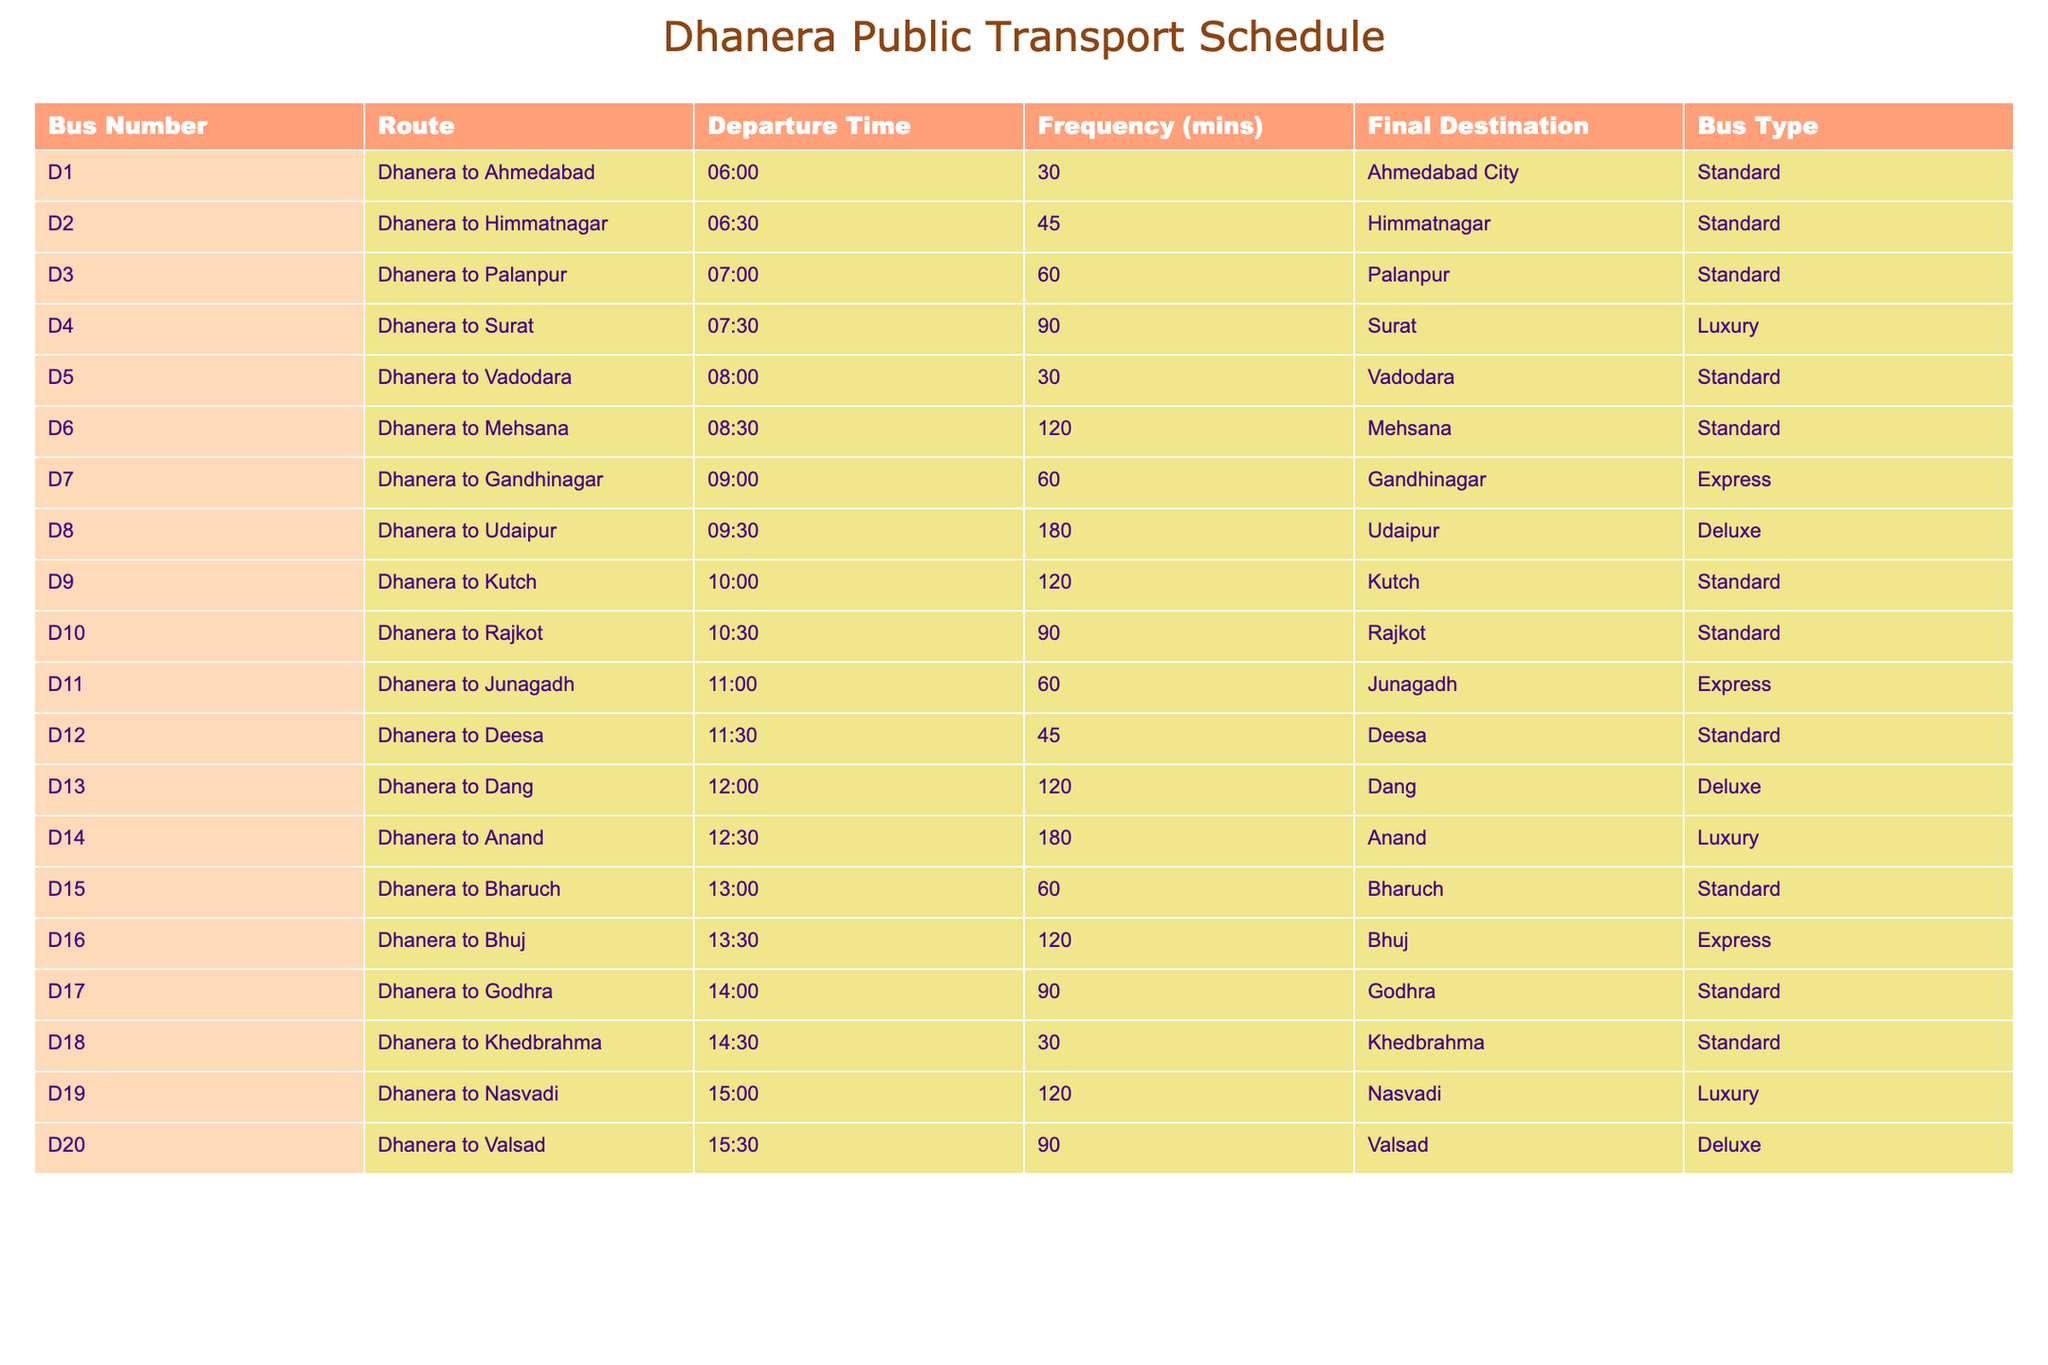What is the first bus to Ahmedabad? The table shows D1 is the bus number for the route from Dhanera to Ahmedabad and that it departs at 06:00.
Answer: D1 How frequently do buses to Himmatnagar run? The frequency for the Dhanera to Himmatnagar route (D2) is listed as 45 minutes.
Answer: 45 minutes What is the final destination of bus number D4? By checking bus number D4 in the table, it indicates that the final destination is Surat.
Answer: Surat Which bus route has the longest frequency? By comparing the frequencies listed, the longest frequency is 180 minutes for buses to Udaipur (D8) and Anand (D14).
Answer: Udaipur and Anand How many buses depart from Dhanera between 06:00 and 09:00? Counting the departures listed from 06:00 to 09:00, buses D1, D2, D3, D4, D5, and D6 depart during this time, totaling six buses.
Answer: 6 Is there a bus to Mehsana after 08:30? D6 departs to Mehsana at 08:30, which is the only bus listed for this route, meaning there are no further departures afterward.
Answer: No What type of bus travels to Rajkot? The table indicates that the bus number D10 traveling to Rajkot is a Standard type.
Answer: Standard What is the average frequency of buses departing after 13:00? The buses departing after 13:00 are D15 (60 mins), D16 (120 mins), D17 (90 mins), D18 (30 mins), D19 (120 mins), and D20 (90 mins). Adding these gives 60 + 120 + 90 + 30 + 120 + 90 = 510 minutes. There are 6 buses, so 510/6 = 85 minutes average frequency.
Answer: 85 minutes Which bus has a departure time closest to noon? Comparing the departure times around noon, D12 to Deesa at 11:30 is just before noon, and D13 to Dang at 12:00 is at noon, making D13 the closest.
Answer: D13 Are there more buses to destinations with Standard type or Deluxe type? Reviewing the table, there are 12 Standard buses and 3 Deluxe buses. Thus, there are more Standard buses.
Answer: Standard type has more (12 vs 3) 